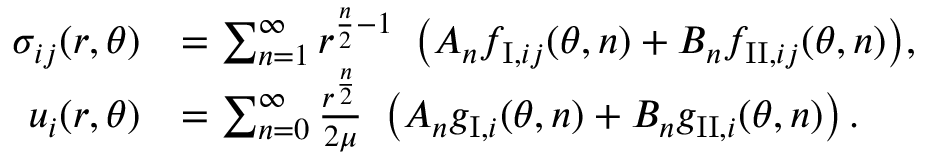<formula> <loc_0><loc_0><loc_500><loc_500>\begin{array} { r l } { \sigma _ { i j } ( r , \theta ) } & { = \sum _ { n = 1 } ^ { \infty } { r ^ { \frac { n } { 2 } - 1 } \ \left ( A _ { n } f _ { I , i j } ( \theta , n ) + B _ { n } f _ { I I , i j } ( \theta , n ) \right ) } , } \\ { u _ { i } ( r , \theta ) } & { = \sum _ { n = 0 } ^ { \infty } \frac { r ^ { \frac { n } { 2 } } } { 2 \mu } \ \left ( A _ { n } g _ { I , i } ( \theta , n ) + B _ { n } g _ { I I , i } ( \theta , n ) \right ) . } \end{array}</formula> 